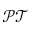<formula> <loc_0><loc_0><loc_500><loc_500>\mathcal { P T }</formula> 